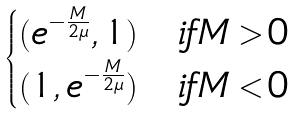Convert formula to latex. <formula><loc_0><loc_0><loc_500><loc_500>\begin{cases} ( e ^ { - \frac { M } { 2 \mu } } , 1 ) & i f M > 0 \\ ( 1 , e ^ { - \frac { M } { 2 \mu } } ) & i f M < 0 \end{cases}</formula> 